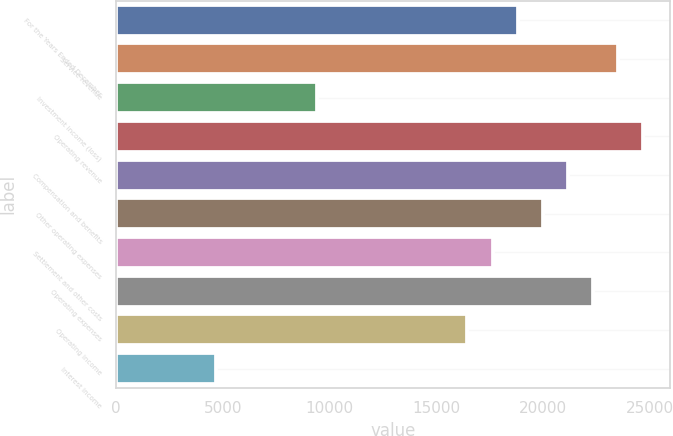Convert chart to OTSL. <chart><loc_0><loc_0><loc_500><loc_500><bar_chart><fcel>For the Years Ended December<fcel>Service revenue<fcel>Investment income (loss)<fcel>Operating revenue<fcel>Compensation and benefits<fcel>Other operating expenses<fcel>Settlement and other costs<fcel>Operating expenses<fcel>Operating income<fcel>Interest income<nl><fcel>18817.4<fcel>23521.7<fcel>9408.85<fcel>24697.8<fcel>21169.5<fcel>19993.5<fcel>17641.3<fcel>22345.6<fcel>16465.3<fcel>4704.57<nl></chart> 